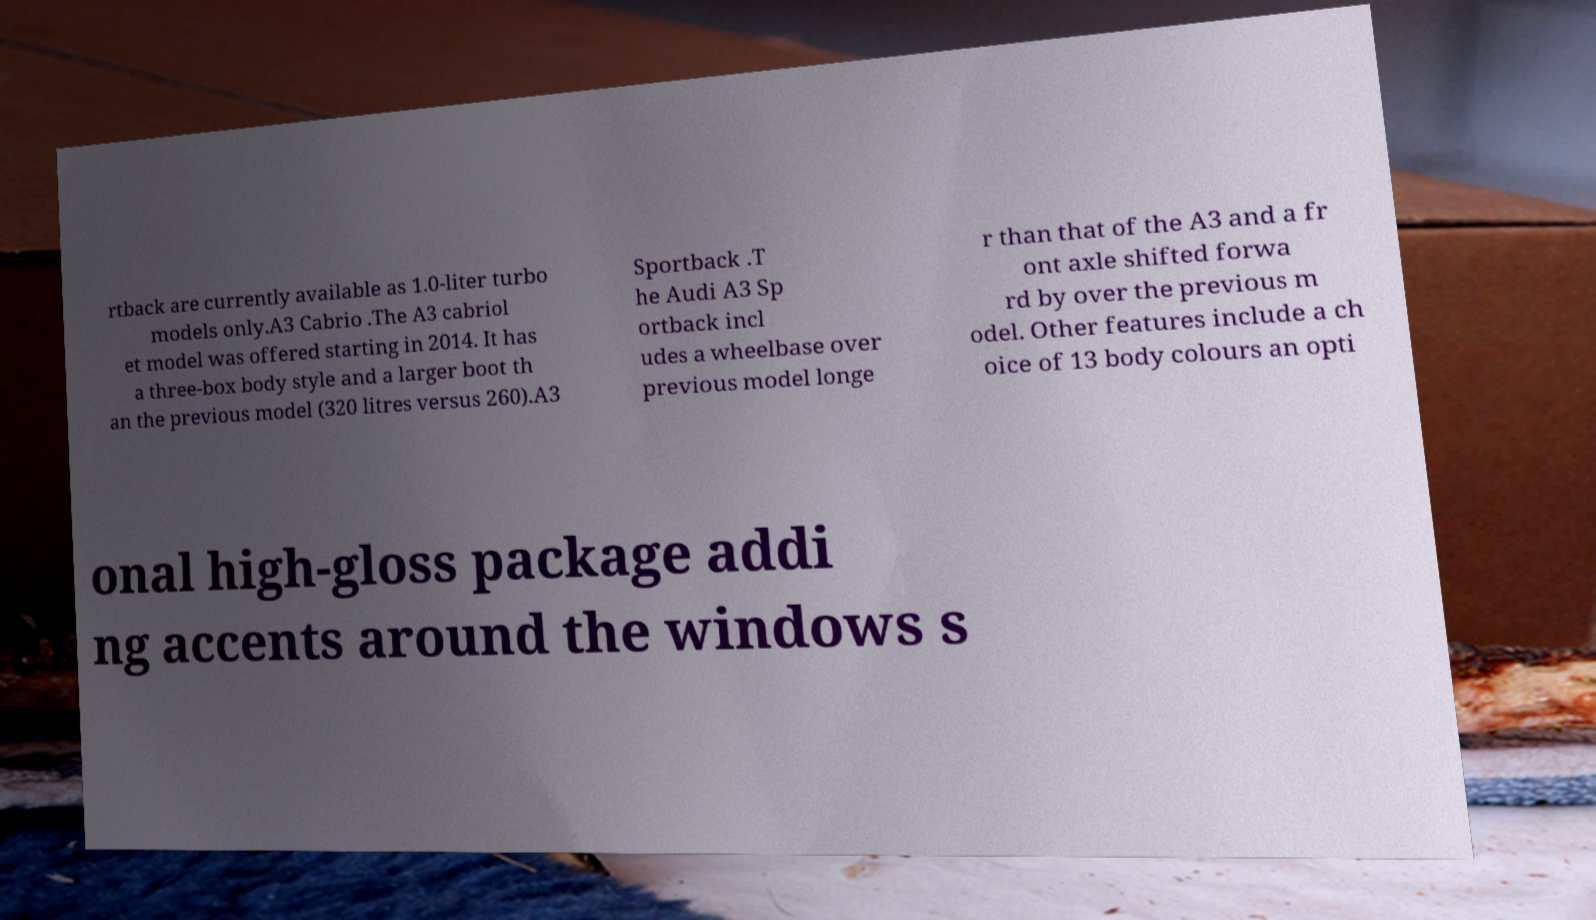Could you assist in decoding the text presented in this image and type it out clearly? rtback are currently available as 1.0-liter turbo models only.A3 Cabrio .The A3 cabriol et model was offered starting in 2014. It has a three-box body style and a larger boot th an the previous model (320 litres versus 260).A3 Sportback .T he Audi A3 Sp ortback incl udes a wheelbase over previous model longe r than that of the A3 and a fr ont axle shifted forwa rd by over the previous m odel. Other features include a ch oice of 13 body colours an opti onal high-gloss package addi ng accents around the windows s 